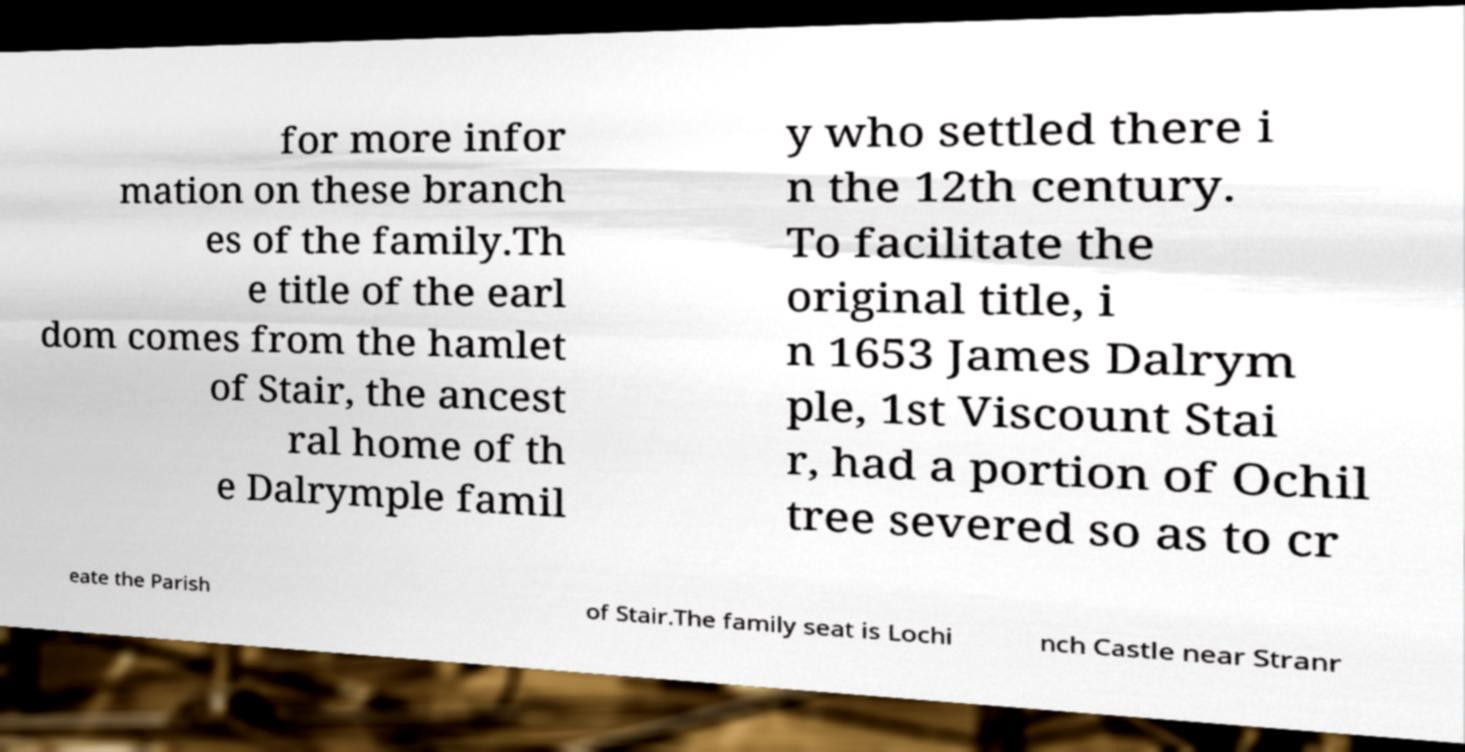What messages or text are displayed in this image? I need them in a readable, typed format. for more infor mation on these branch es of the family.Th e title of the earl dom comes from the hamlet of Stair, the ancest ral home of th e Dalrymple famil y who settled there i n the 12th century. To facilitate the original title, i n 1653 James Dalrym ple, 1st Viscount Stai r, had a portion of Ochil tree severed so as to cr eate the Parish of Stair.The family seat is Lochi nch Castle near Stranr 